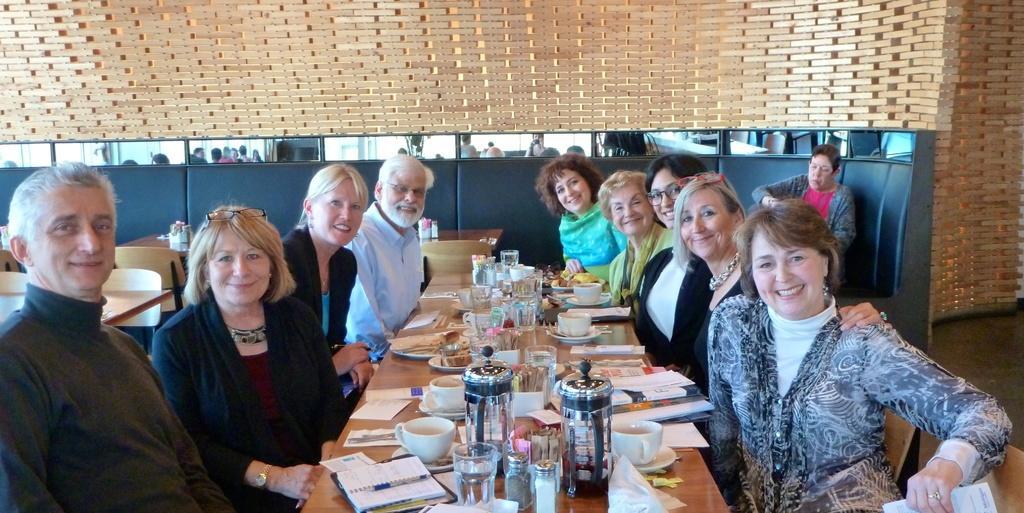Can you describe this image briefly? In this picture, In the middle there is a table which is in yellow color, There are some books which are in white color, There are some glasses, There are some jugs, There are some cups which are in white color, There are some people sitting on the chairs around the table, In the background there is a black color wall, In the top there is a yellow color wooden blocks. 